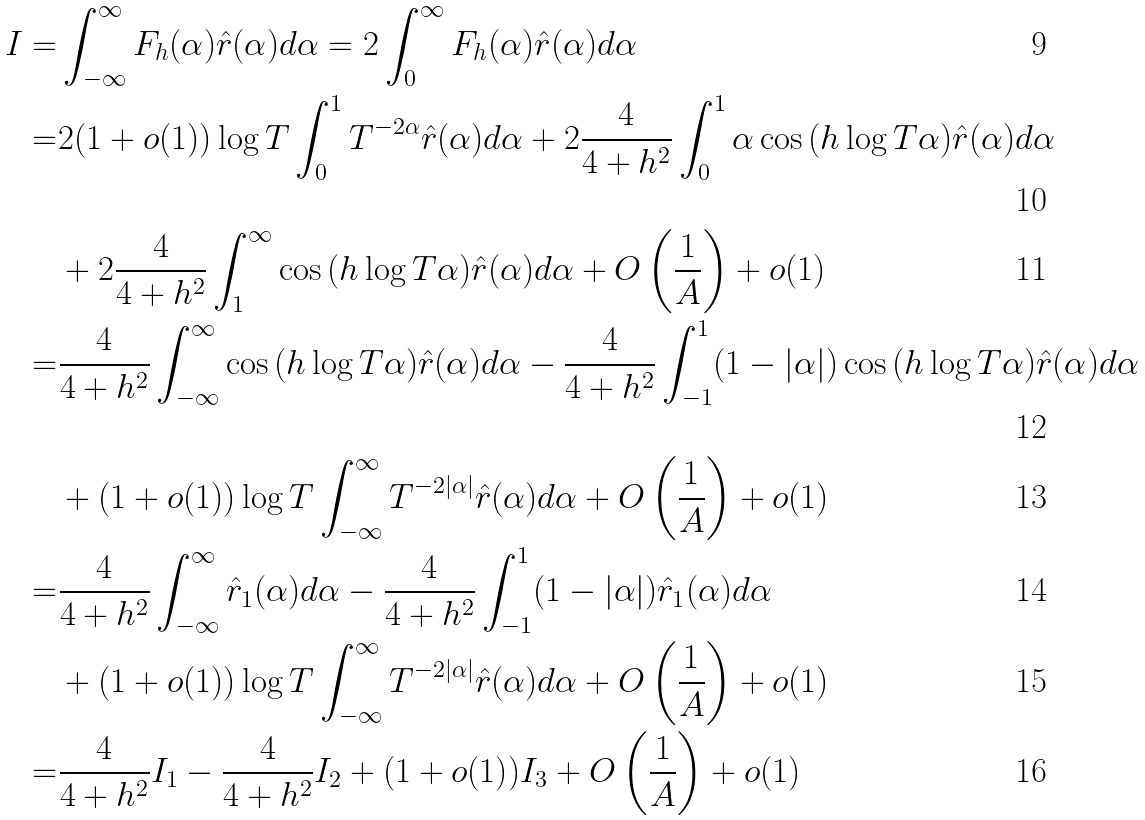<formula> <loc_0><loc_0><loc_500><loc_500>I = & \int _ { - \infty } ^ { \infty } F _ { h } ( \alpha ) \hat { r } ( \alpha ) d \alpha = 2 \int _ { 0 } ^ { \infty } F _ { h } ( \alpha ) \hat { r } ( \alpha ) d \alpha \\ = & 2 ( 1 + o ( 1 ) ) \log { T } \int _ { 0 } ^ { 1 } T ^ { - 2 \alpha } \hat { r } ( \alpha ) d \alpha + 2 \frac { 4 } { 4 + h ^ { 2 } } \int _ { 0 } ^ { 1 } \alpha \cos { ( h \log { T } \alpha ) } \hat { r } ( \alpha ) d \alpha \\ & + 2 \frac { 4 } { 4 + h ^ { 2 } } \int _ { 1 } ^ { \infty } \cos { ( h \log { T } \alpha ) } \hat { r } ( \alpha ) d \alpha + O \left ( \frac { 1 } { A } \right ) + o ( 1 ) \\ = & \frac { 4 } { 4 + h ^ { 2 } } \int _ { - \infty } ^ { \infty } \cos { ( h \log { T } \alpha ) } \hat { r } ( \alpha ) d \alpha - \frac { 4 } { 4 + h ^ { 2 } } \int _ { - 1 } ^ { 1 } ( 1 - | \alpha | ) \cos { ( h \log { T } \alpha ) } \hat { r } ( \alpha ) d \alpha \\ & + ( 1 + o ( 1 ) ) \log { T } \int _ { - \infty } ^ { \infty } T ^ { - 2 | \alpha | } \hat { r } ( \alpha ) d \alpha + O \left ( \frac { 1 } { A } \right ) + o ( 1 ) \\ = & \frac { 4 } { 4 + h ^ { 2 } } \int _ { - \infty } ^ { \infty } \hat { r } _ { 1 } ( \alpha ) d \alpha - \frac { 4 } { 4 + h ^ { 2 } } \int _ { - 1 } ^ { 1 } ( 1 - | \alpha | ) \hat { r } _ { 1 } ( \alpha ) d \alpha \\ & + ( 1 + o ( 1 ) ) \log { T } \int _ { - \infty } ^ { \infty } T ^ { - 2 | \alpha | } \hat { r } ( \alpha ) d \alpha + O \left ( \frac { 1 } { A } \right ) + o ( 1 ) \\ = & \frac { 4 } { 4 + h ^ { 2 } } I _ { 1 } - \frac { 4 } { 4 + h ^ { 2 } } I _ { 2 } + ( 1 + o ( 1 ) ) I _ { 3 } + O \left ( \frac { 1 } { A } \right ) + o ( 1 )</formula> 